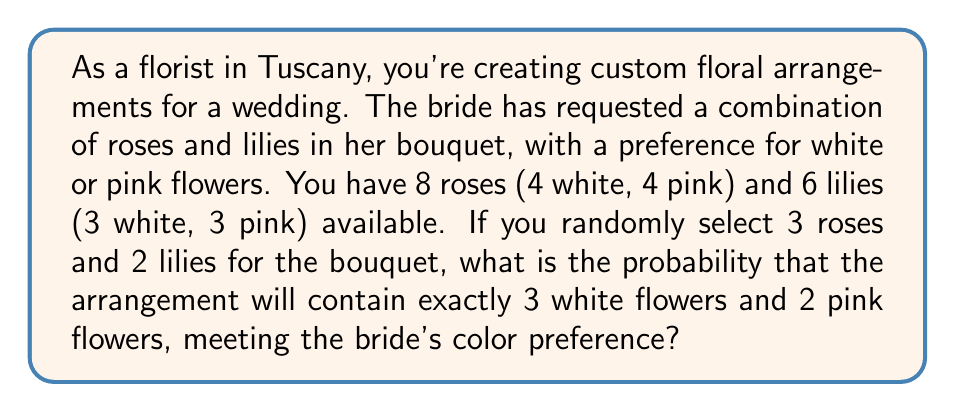Show me your answer to this math problem. Let's approach this step-by-step:

1) We need to select 3 roses and 2 lilies, with a total of 3 white flowers and 2 pink flowers.

2) We can break this down into two cases:
   Case A: 2 white roses, 1 pink rose, 1 white lily, 1 pink lily
   Case B: 1 white rose, 2 pink roses, 2 white lilies, 0 pink lilies

3) Let's calculate the probability of each case:

   Case A:
   - Probability of selecting 2 white roses out of 4 and 1 pink rose out of 4:
     $$P(\text{roses}) = \frac{\binom{4}{2} \cdot \binom{4}{1}}{\binom{8}{3}} = \frac{6 \cdot 4}{56} = \frac{24}{56}$$
   - Probability of selecting 1 white lily out of 3 and 1 pink lily out of 3:
     $$P(\text{lilies}) = \frac{\binom{3}{1} \cdot \binom{3}{1}}{\binom{6}{2}} = \frac{3 \cdot 3}{15} = \frac{9}{15}$$
   - Probability of Case A: $$P(A) = \frac{24}{56} \cdot \frac{9}{15} = \frac{216}{840} = \frac{27}{105}$$

   Case B:
   - Probability of selecting 1 white rose out of 4 and 2 pink roses out of 4:
     $$P(\text{roses}) = \frac{\binom{4}{1} \cdot \binom{4}{2}}{\binom{8}{3}} = \frac{4 \cdot 6}{56} = \frac{24}{56}$$
   - Probability of selecting 2 white lilies out of 3 and 0 pink lilies out of 3:
     $$P(\text{lilies}) = \frac{\binom{3}{2} \cdot \binom{3}{0}}{\binom{6}{2}} = \frac{3 \cdot 1}{15} = \frac{3}{15}$$
   - Probability of Case B: $$P(B) = \frac{24}{56} \cdot \frac{3}{15} = \frac{72}{840} = \frac{9}{105}$$

4) The total probability is the sum of the probabilities of Case A and Case B:
   $$P(\text{total}) = P(A) + P(B) = \frac{27}{105} + \frac{9}{105} = \frac{36}{105} = \frac{12}{35}$$
Answer: The probability of creating an arrangement with exactly 3 white flowers and 2 pink flowers is $\frac{12}{35}$ or approximately 0.3429 or 34.29%. 